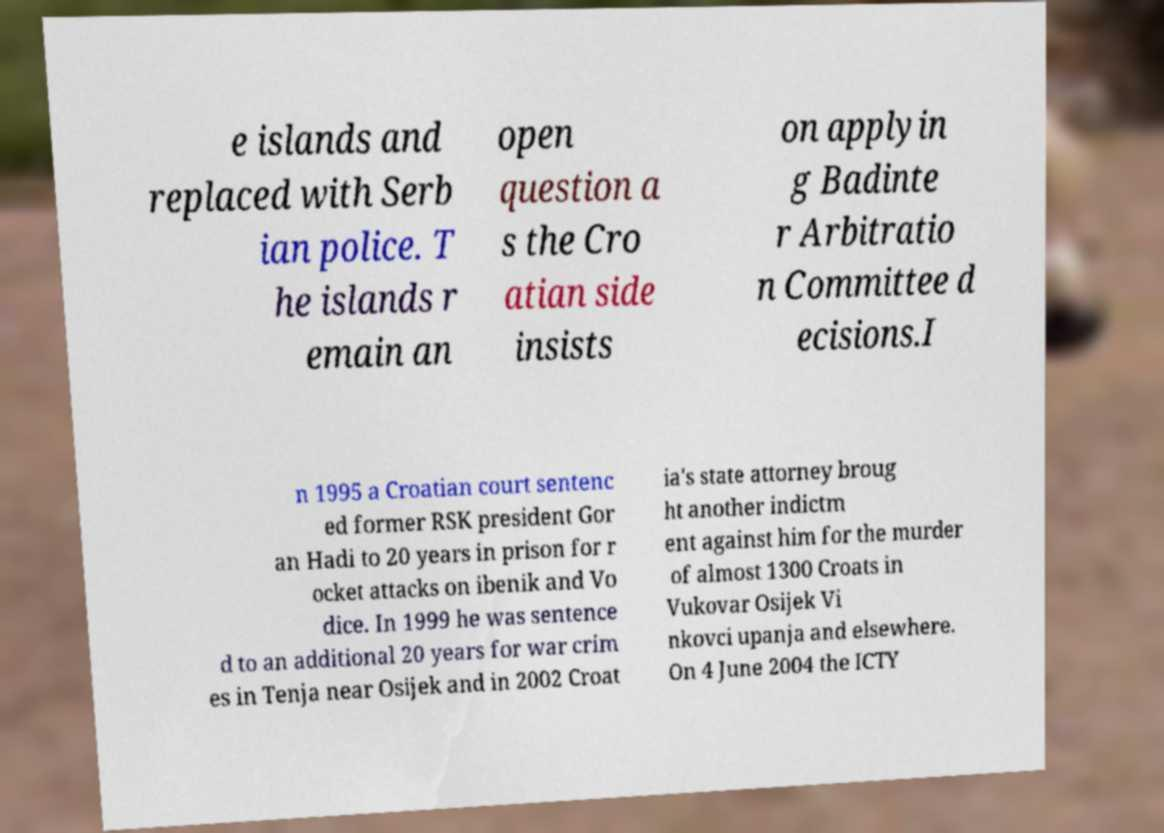Please read and relay the text visible in this image. What does it say? e islands and replaced with Serb ian police. T he islands r emain an open question a s the Cro atian side insists on applyin g Badinte r Arbitratio n Committee d ecisions.I n 1995 a Croatian court sentenc ed former RSK president Gor an Hadi to 20 years in prison for r ocket attacks on ibenik and Vo dice. In 1999 he was sentence d to an additional 20 years for war crim es in Tenja near Osijek and in 2002 Croat ia's state attorney broug ht another indictm ent against him for the murder of almost 1300 Croats in Vukovar Osijek Vi nkovci upanja and elsewhere. On 4 June 2004 the ICTY 